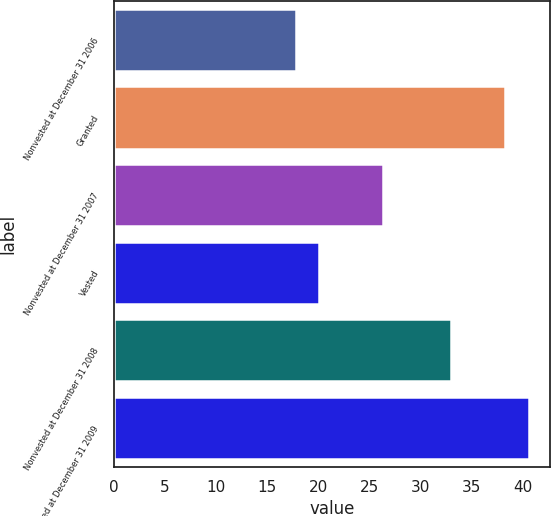Convert chart. <chart><loc_0><loc_0><loc_500><loc_500><bar_chart><fcel>Nonvested at December 31 2006<fcel>Granted<fcel>Nonvested at December 31 2007<fcel>Vested<fcel>Nonvested at December 31 2008<fcel>Nonvested at December 31 2009<nl><fcel>17.8<fcel>38.21<fcel>26.34<fcel>20.08<fcel>32.98<fcel>40.63<nl></chart> 